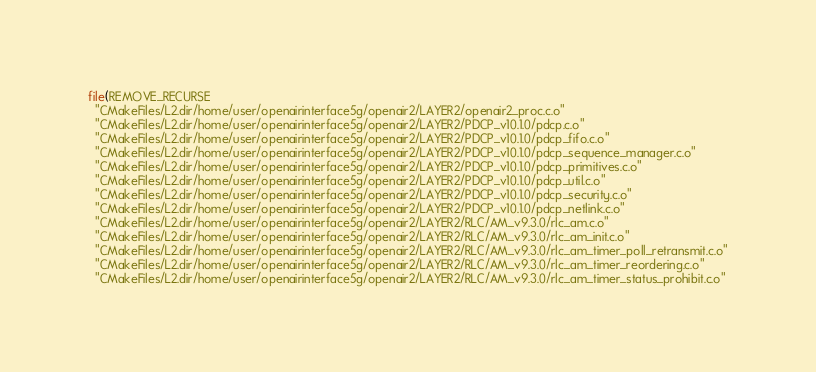Convert code to text. <code><loc_0><loc_0><loc_500><loc_500><_CMake_>file(REMOVE_RECURSE
  "CMakeFiles/L2.dir/home/user/openairinterface5g/openair2/LAYER2/openair2_proc.c.o"
  "CMakeFiles/L2.dir/home/user/openairinterface5g/openair2/LAYER2/PDCP_v10.1.0/pdcp.c.o"
  "CMakeFiles/L2.dir/home/user/openairinterface5g/openair2/LAYER2/PDCP_v10.1.0/pdcp_fifo.c.o"
  "CMakeFiles/L2.dir/home/user/openairinterface5g/openair2/LAYER2/PDCP_v10.1.0/pdcp_sequence_manager.c.o"
  "CMakeFiles/L2.dir/home/user/openairinterface5g/openair2/LAYER2/PDCP_v10.1.0/pdcp_primitives.c.o"
  "CMakeFiles/L2.dir/home/user/openairinterface5g/openair2/LAYER2/PDCP_v10.1.0/pdcp_util.c.o"
  "CMakeFiles/L2.dir/home/user/openairinterface5g/openair2/LAYER2/PDCP_v10.1.0/pdcp_security.c.o"
  "CMakeFiles/L2.dir/home/user/openairinterface5g/openair2/LAYER2/PDCP_v10.1.0/pdcp_netlink.c.o"
  "CMakeFiles/L2.dir/home/user/openairinterface5g/openair2/LAYER2/RLC/AM_v9.3.0/rlc_am.c.o"
  "CMakeFiles/L2.dir/home/user/openairinterface5g/openair2/LAYER2/RLC/AM_v9.3.0/rlc_am_init.c.o"
  "CMakeFiles/L2.dir/home/user/openairinterface5g/openair2/LAYER2/RLC/AM_v9.3.0/rlc_am_timer_poll_retransmit.c.o"
  "CMakeFiles/L2.dir/home/user/openairinterface5g/openair2/LAYER2/RLC/AM_v9.3.0/rlc_am_timer_reordering.c.o"
  "CMakeFiles/L2.dir/home/user/openairinterface5g/openair2/LAYER2/RLC/AM_v9.3.0/rlc_am_timer_status_prohibit.c.o"</code> 